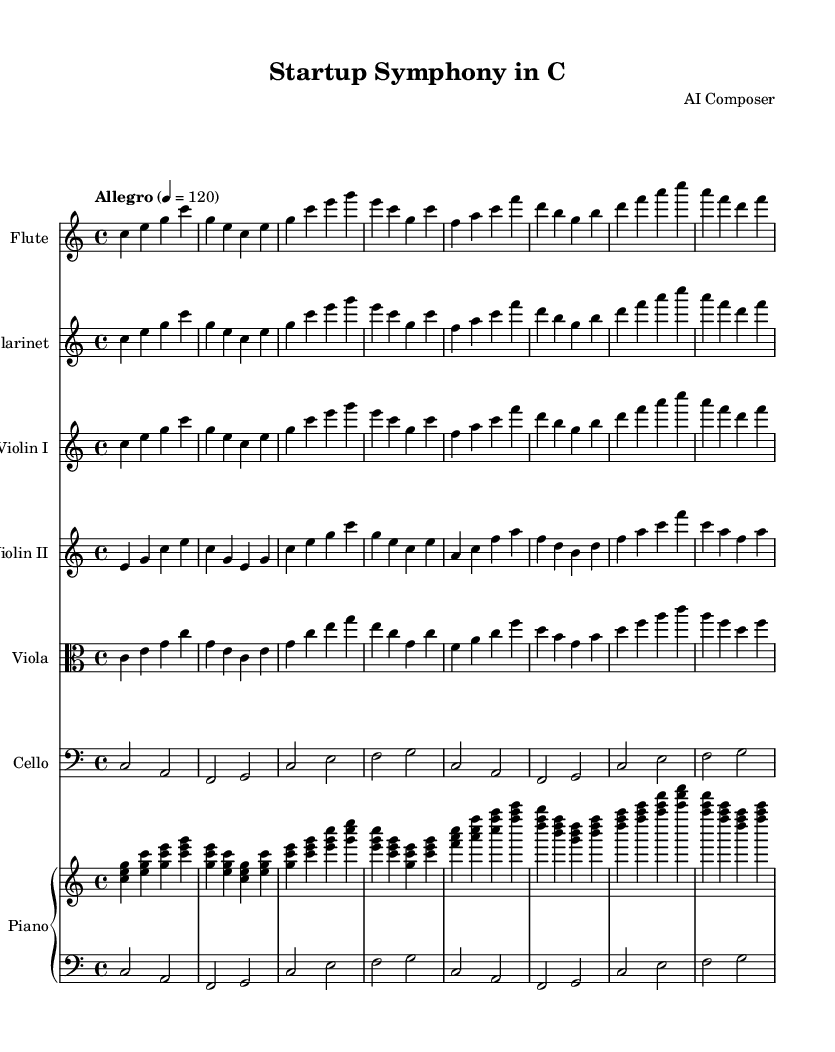What is the key signature of this music? The key signature shown is C major, which is identified by the absence of any sharps or flats. This can be confirmed by looking at the upper left section of the sheet music where the key signature is indicated.
Answer: C major What is the time signature of this music? The time signature presented in the sheet music is 4/4, which means there are four beats in each measure and a quarter note gets one beat. This is usually indicated at the beginning of the score, and in this case, it is clearly shown next to the clef.
Answer: 4/4 What is the tempo marking of this music? The tempo marking indicated in the sheet music is "Allegro," which means to play at a fast, lively tempo. The specific beats per minute are given as 120, and this information helps musicians understand how quickly to perform the piece.
Answer: Allegro How many measures are present in the flute part? By counting the number of vertical bar lines that separate the music into sections (measures) in the flute part, we find a total of 8 measures. The rest of the parts have a similar number of measures, indicating a consistent structure throughout the symphony.
Answer: 8 Which instruments are included in this symphony? The instruments listed in the score include flute, clarinet, violin I, violin II, viola, cello, and piano. This information is typically found at the beginning of each staff, and this particular combination suggests a chamber music setting, characteristic of a minimalist symphony.
Answer: Flute, clarinet, violin I, violin II, viola, cello, piano What notes are played in the first measure of the violin I part? The first measure of the violin I part consists of the notes C, E, and G, which form a C major chord. Observing the notations in that measure gives us these specific pitches, confirming the harmonic structure introduced at the beginning of the piece.
Answer: C, E, G What is the overall mood conveyed by the tempo and dynamics in this symphony? The overall mood is lively and energetic, as indicated by the fast tempo marking "Allegro" and the use of sustained notes combined with active melodic lines. This balance reflects the efficiency and forward momentum associated with modern startups, resonating with the theme of the symphony.
Answer: Lively, energetic 